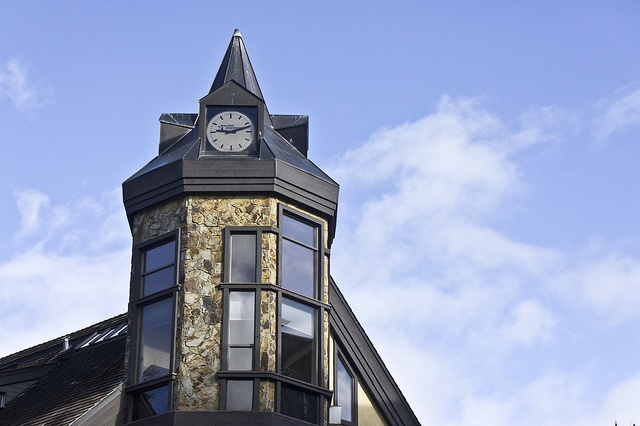Describe the objects in this image and their specific colors. I can see a clock in lightblue, darkgray, gray, and black tones in this image. 